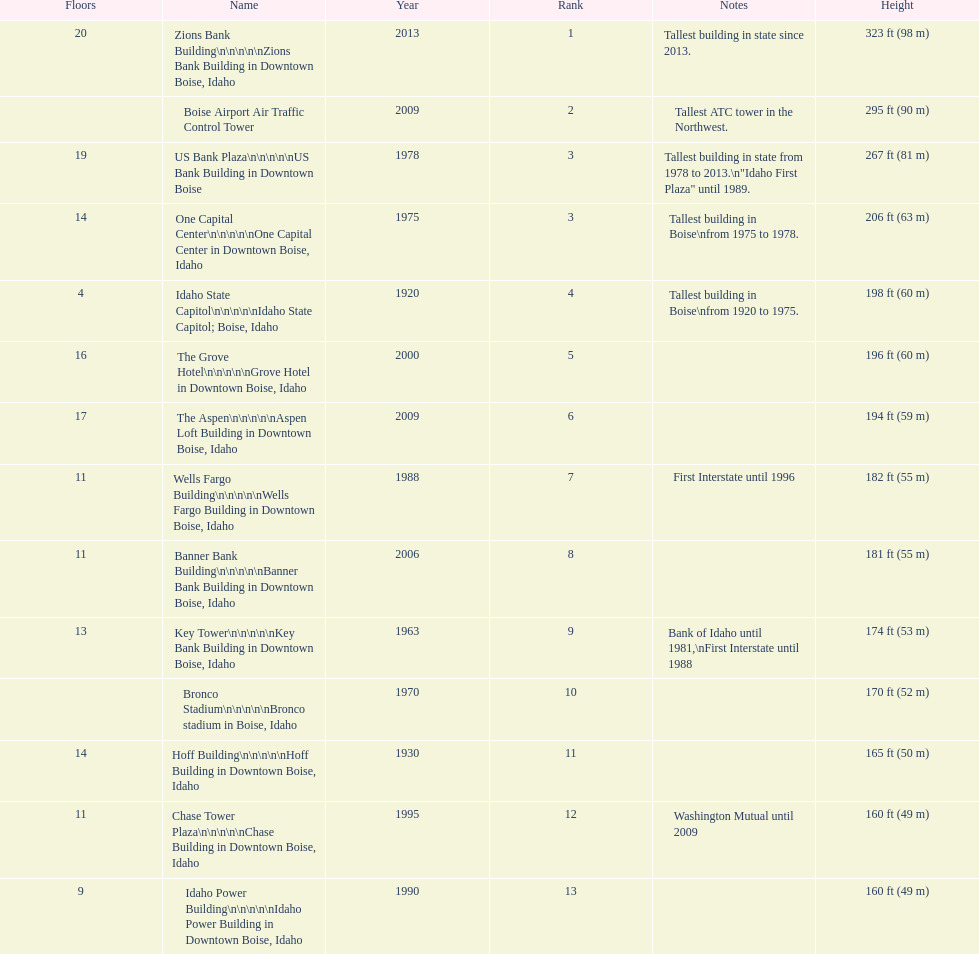What is the name of the building listed after idaho state capitol? The Grove Hotel. 